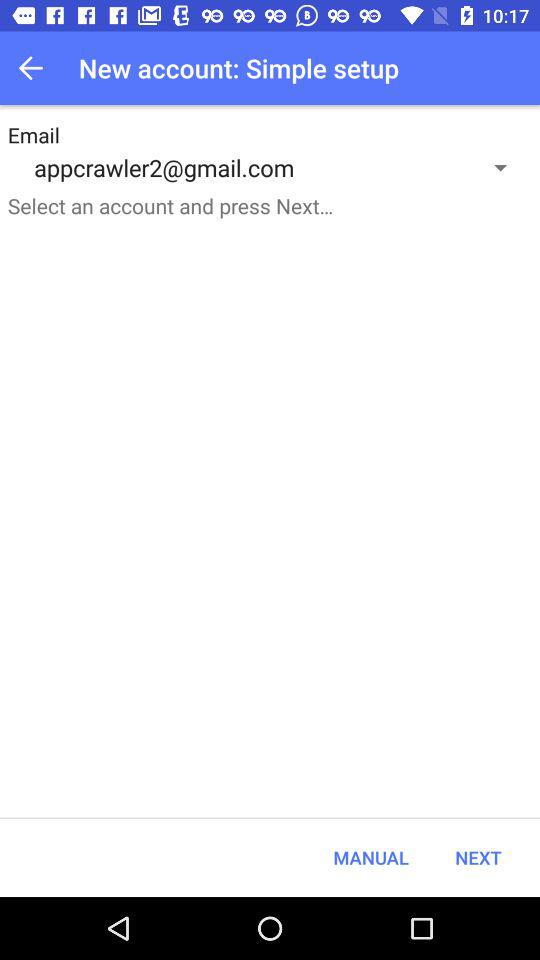What's the Google Mail address? The Gmail address is appcrawler2@gmail.com. 